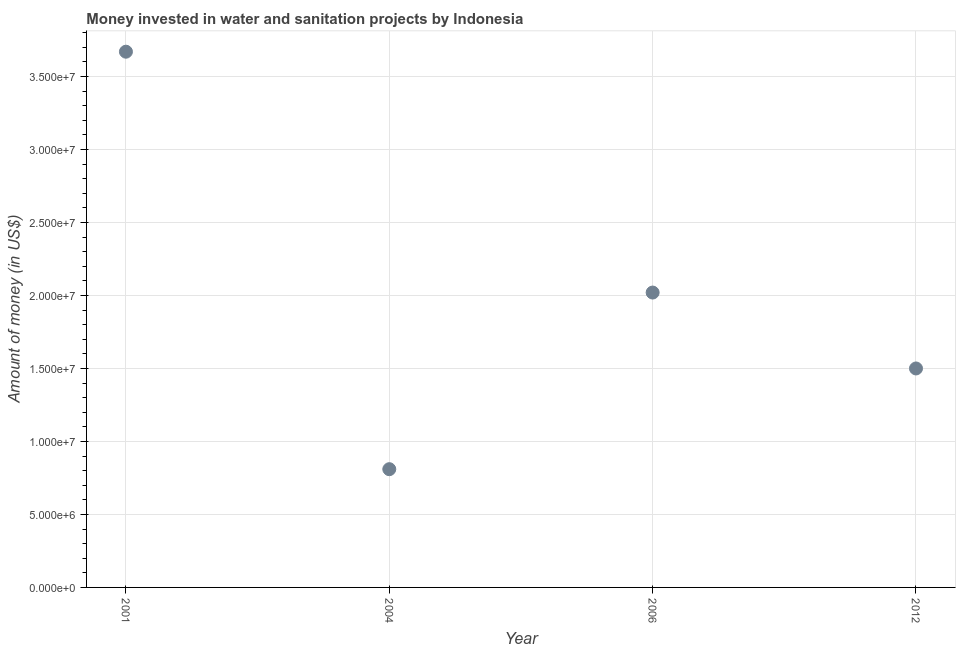What is the investment in 2006?
Provide a succinct answer. 2.02e+07. Across all years, what is the maximum investment?
Offer a very short reply. 3.67e+07. Across all years, what is the minimum investment?
Offer a very short reply. 8.10e+06. What is the sum of the investment?
Your response must be concise. 8.00e+07. What is the difference between the investment in 2004 and 2012?
Offer a very short reply. -6.90e+06. What is the average investment per year?
Your response must be concise. 2.00e+07. What is the median investment?
Your answer should be very brief. 1.76e+07. What is the ratio of the investment in 2004 to that in 2006?
Provide a short and direct response. 0.4. What is the difference between the highest and the second highest investment?
Your response must be concise. 1.65e+07. Is the sum of the investment in 2004 and 2006 greater than the maximum investment across all years?
Offer a very short reply. No. What is the difference between the highest and the lowest investment?
Provide a short and direct response. 2.86e+07. In how many years, is the investment greater than the average investment taken over all years?
Your response must be concise. 2. Does the investment monotonically increase over the years?
Your answer should be very brief. No. How many dotlines are there?
Make the answer very short. 1. Are the values on the major ticks of Y-axis written in scientific E-notation?
Provide a short and direct response. Yes. Does the graph contain grids?
Make the answer very short. Yes. What is the title of the graph?
Your answer should be compact. Money invested in water and sanitation projects by Indonesia. What is the label or title of the X-axis?
Provide a succinct answer. Year. What is the label or title of the Y-axis?
Your response must be concise. Amount of money (in US$). What is the Amount of money (in US$) in 2001?
Your response must be concise. 3.67e+07. What is the Amount of money (in US$) in 2004?
Your answer should be compact. 8.10e+06. What is the Amount of money (in US$) in 2006?
Provide a short and direct response. 2.02e+07. What is the Amount of money (in US$) in 2012?
Your answer should be compact. 1.50e+07. What is the difference between the Amount of money (in US$) in 2001 and 2004?
Your response must be concise. 2.86e+07. What is the difference between the Amount of money (in US$) in 2001 and 2006?
Offer a very short reply. 1.65e+07. What is the difference between the Amount of money (in US$) in 2001 and 2012?
Offer a very short reply. 2.17e+07. What is the difference between the Amount of money (in US$) in 2004 and 2006?
Offer a terse response. -1.21e+07. What is the difference between the Amount of money (in US$) in 2004 and 2012?
Your response must be concise. -6.90e+06. What is the difference between the Amount of money (in US$) in 2006 and 2012?
Offer a terse response. 5.20e+06. What is the ratio of the Amount of money (in US$) in 2001 to that in 2004?
Make the answer very short. 4.53. What is the ratio of the Amount of money (in US$) in 2001 to that in 2006?
Ensure brevity in your answer.  1.82. What is the ratio of the Amount of money (in US$) in 2001 to that in 2012?
Ensure brevity in your answer.  2.45. What is the ratio of the Amount of money (in US$) in 2004 to that in 2006?
Offer a very short reply. 0.4. What is the ratio of the Amount of money (in US$) in 2004 to that in 2012?
Keep it short and to the point. 0.54. What is the ratio of the Amount of money (in US$) in 2006 to that in 2012?
Make the answer very short. 1.35. 